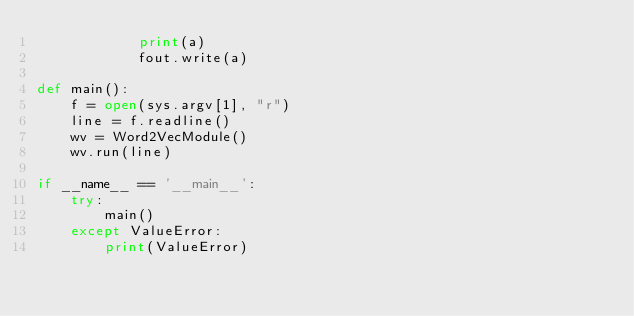Convert code to text. <code><loc_0><loc_0><loc_500><loc_500><_Python_>            print(a)
            fout.write(a)

def main():
    f = open(sys.argv[1], "r")
    line = f.readline()
    wv = Word2VecModule()
    wv.run(line)

if __name__ == '__main__':
    try:
        main()
    except ValueError:
        print(ValueError)

</code> 